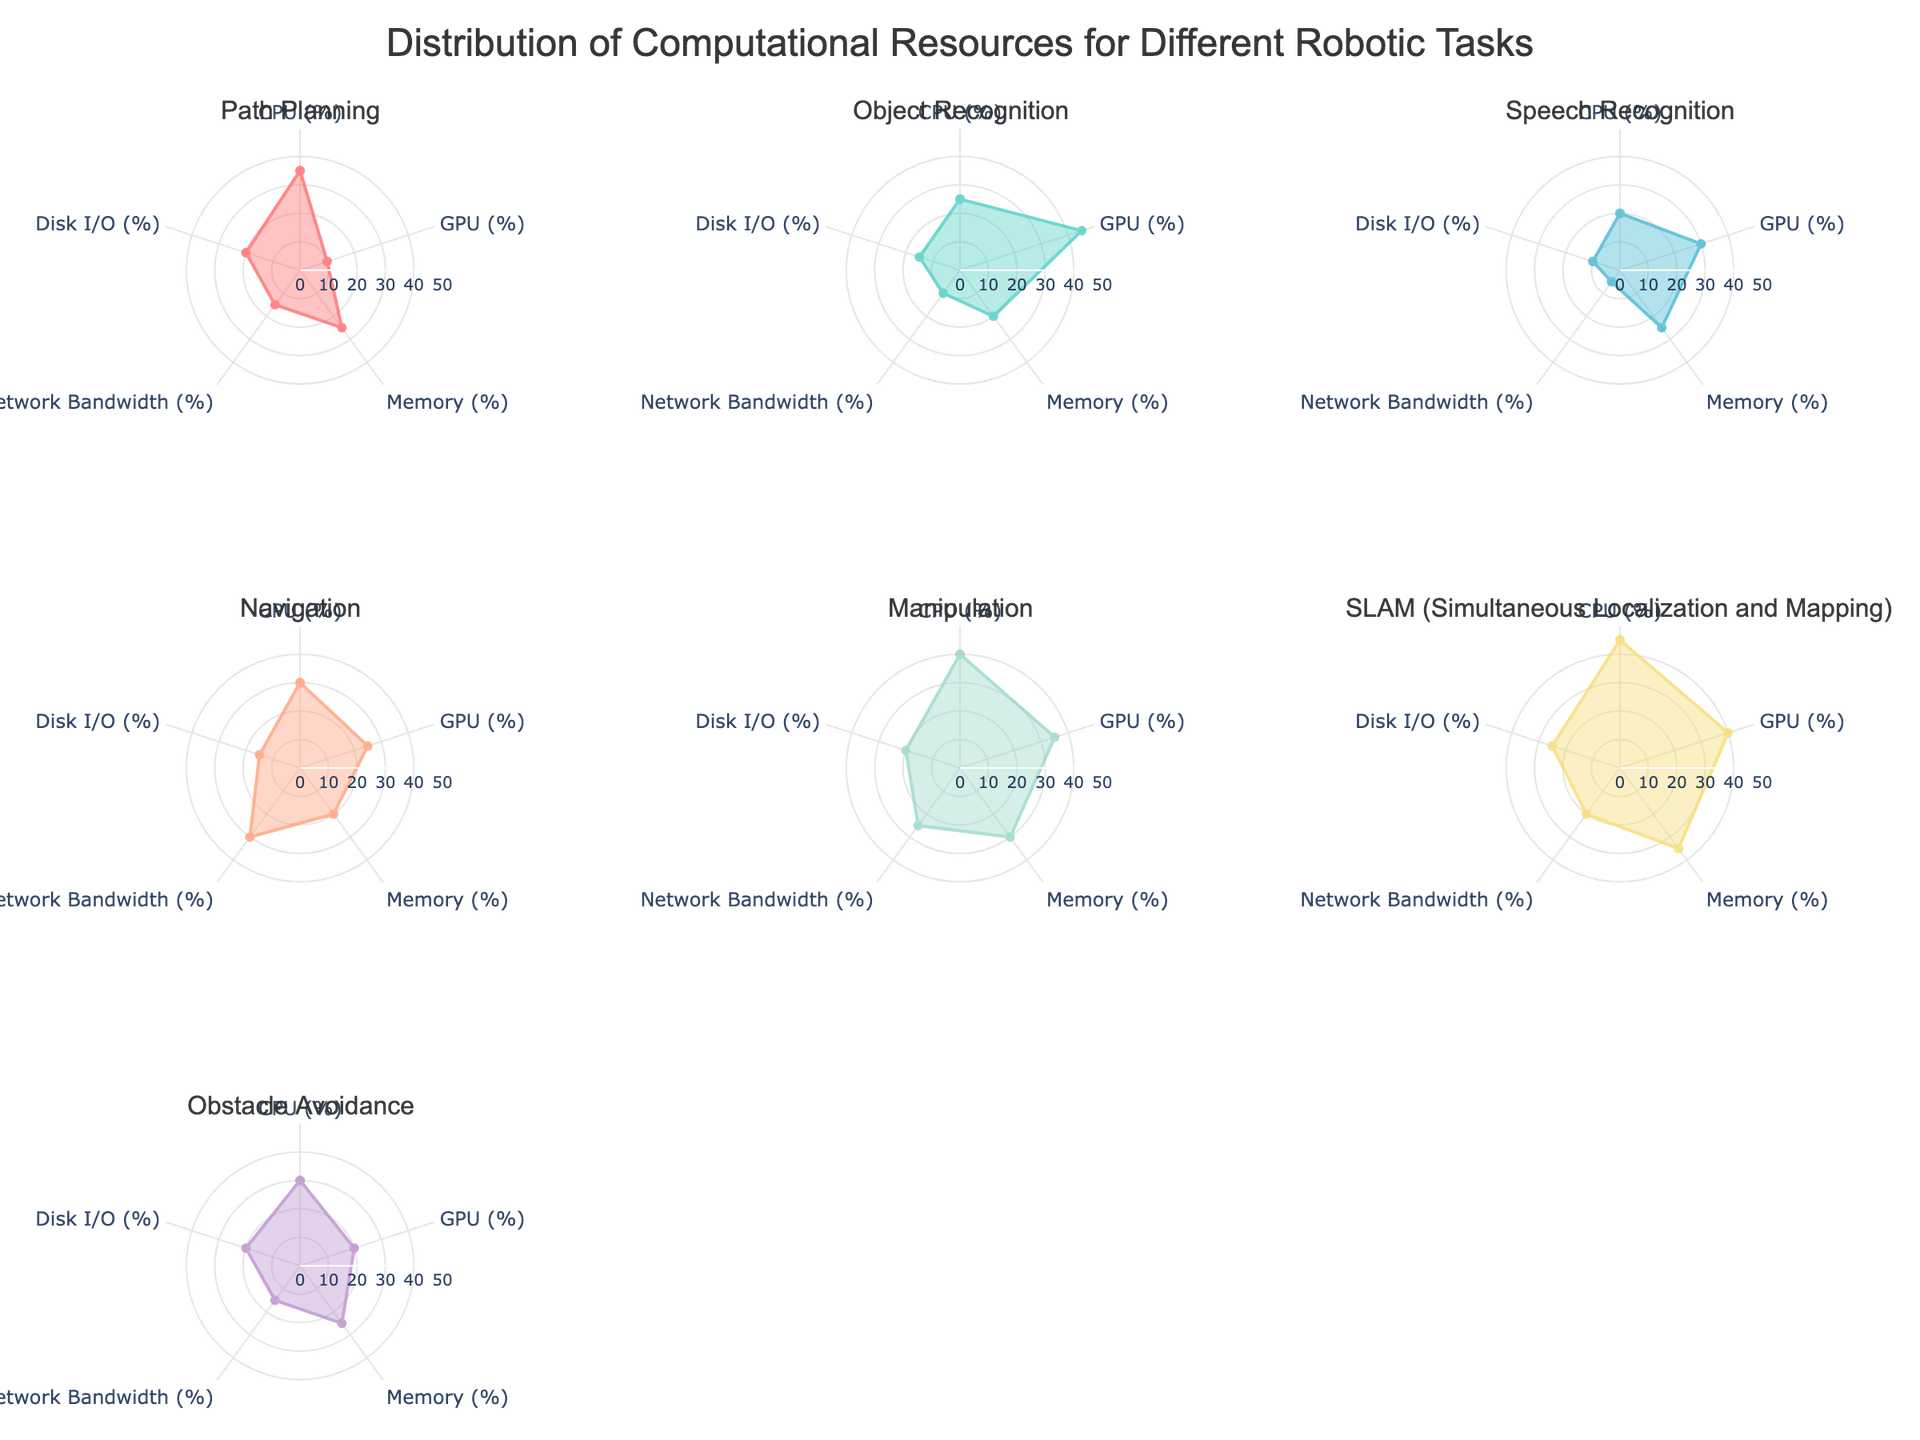What is the title of the figure? The title is usually located at the top of the figure. By examining the rendered image, you will notice the main heading text displayed prominently.
Answer: Distribution of Computational Resources for Different Robotic Tasks Which robotic task requires the most Disk I/O resources? By looking at the subplot for each robotic task and noting the values on the Disk I/O axis, you can identify which one has the highest value.
Answer: SLAM (Simultaneous Localization and Mapping) How many categories are used to measure computational resources? Each radar chart has axes representing different categories. Counting these axes will give us the number of categories.
Answer: Five Which task has the highest GPU usage? In the radar chart subplot, the task with the highest extension in the GPU axis can be identified.
Answer: Object Recognition Compare the CPU usage between Path Planning and Navigation. Which one uses more CPU resources? Locate the CPU axis for both Path Planning and Navigation and compare the values.
Answer: Path Planning Which task shows the highest Memory utilization? Examine the Memory axis in each subplot and determine which task extends furthest along this axis.
Answer: SLAM (Simultaneous Localization and Mapping) What is the sum of Network Bandwidth usage for Speech Recognition and Obstacle Avoidance? Find the value on the Network Bandwidth axis for Speech Recognition and Obstacle Avoidance and add them together.
Answer: 5 + 15 = 20 Among all tasks, which one has the lowest Network Bandwidth usage? Check the Network Bandwidth axis in each subplot to identify the task with the smallest value.
Answer: Speech Recognition Which task has similar values for CPU and Memory usage? Identify the task that has nearly equal lengths in the radar chart for both CPU and Memory axes.
Answer: Path Planning How does the GPU usage for Manipulation compare to that of Navigation? Compare the values on the GPU axis for both Manipulation and Navigation to see which is higher.
Answer: Manipulation uses more GPU 